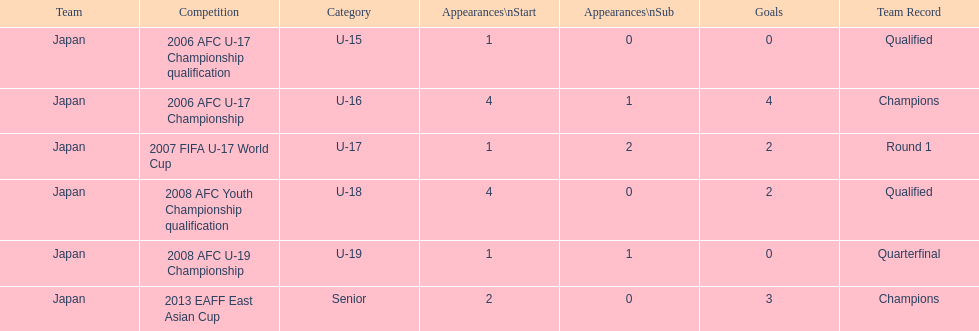What was yoichiro kakitani's first major competition? 2006 AFC U-17 Championship qualification. 